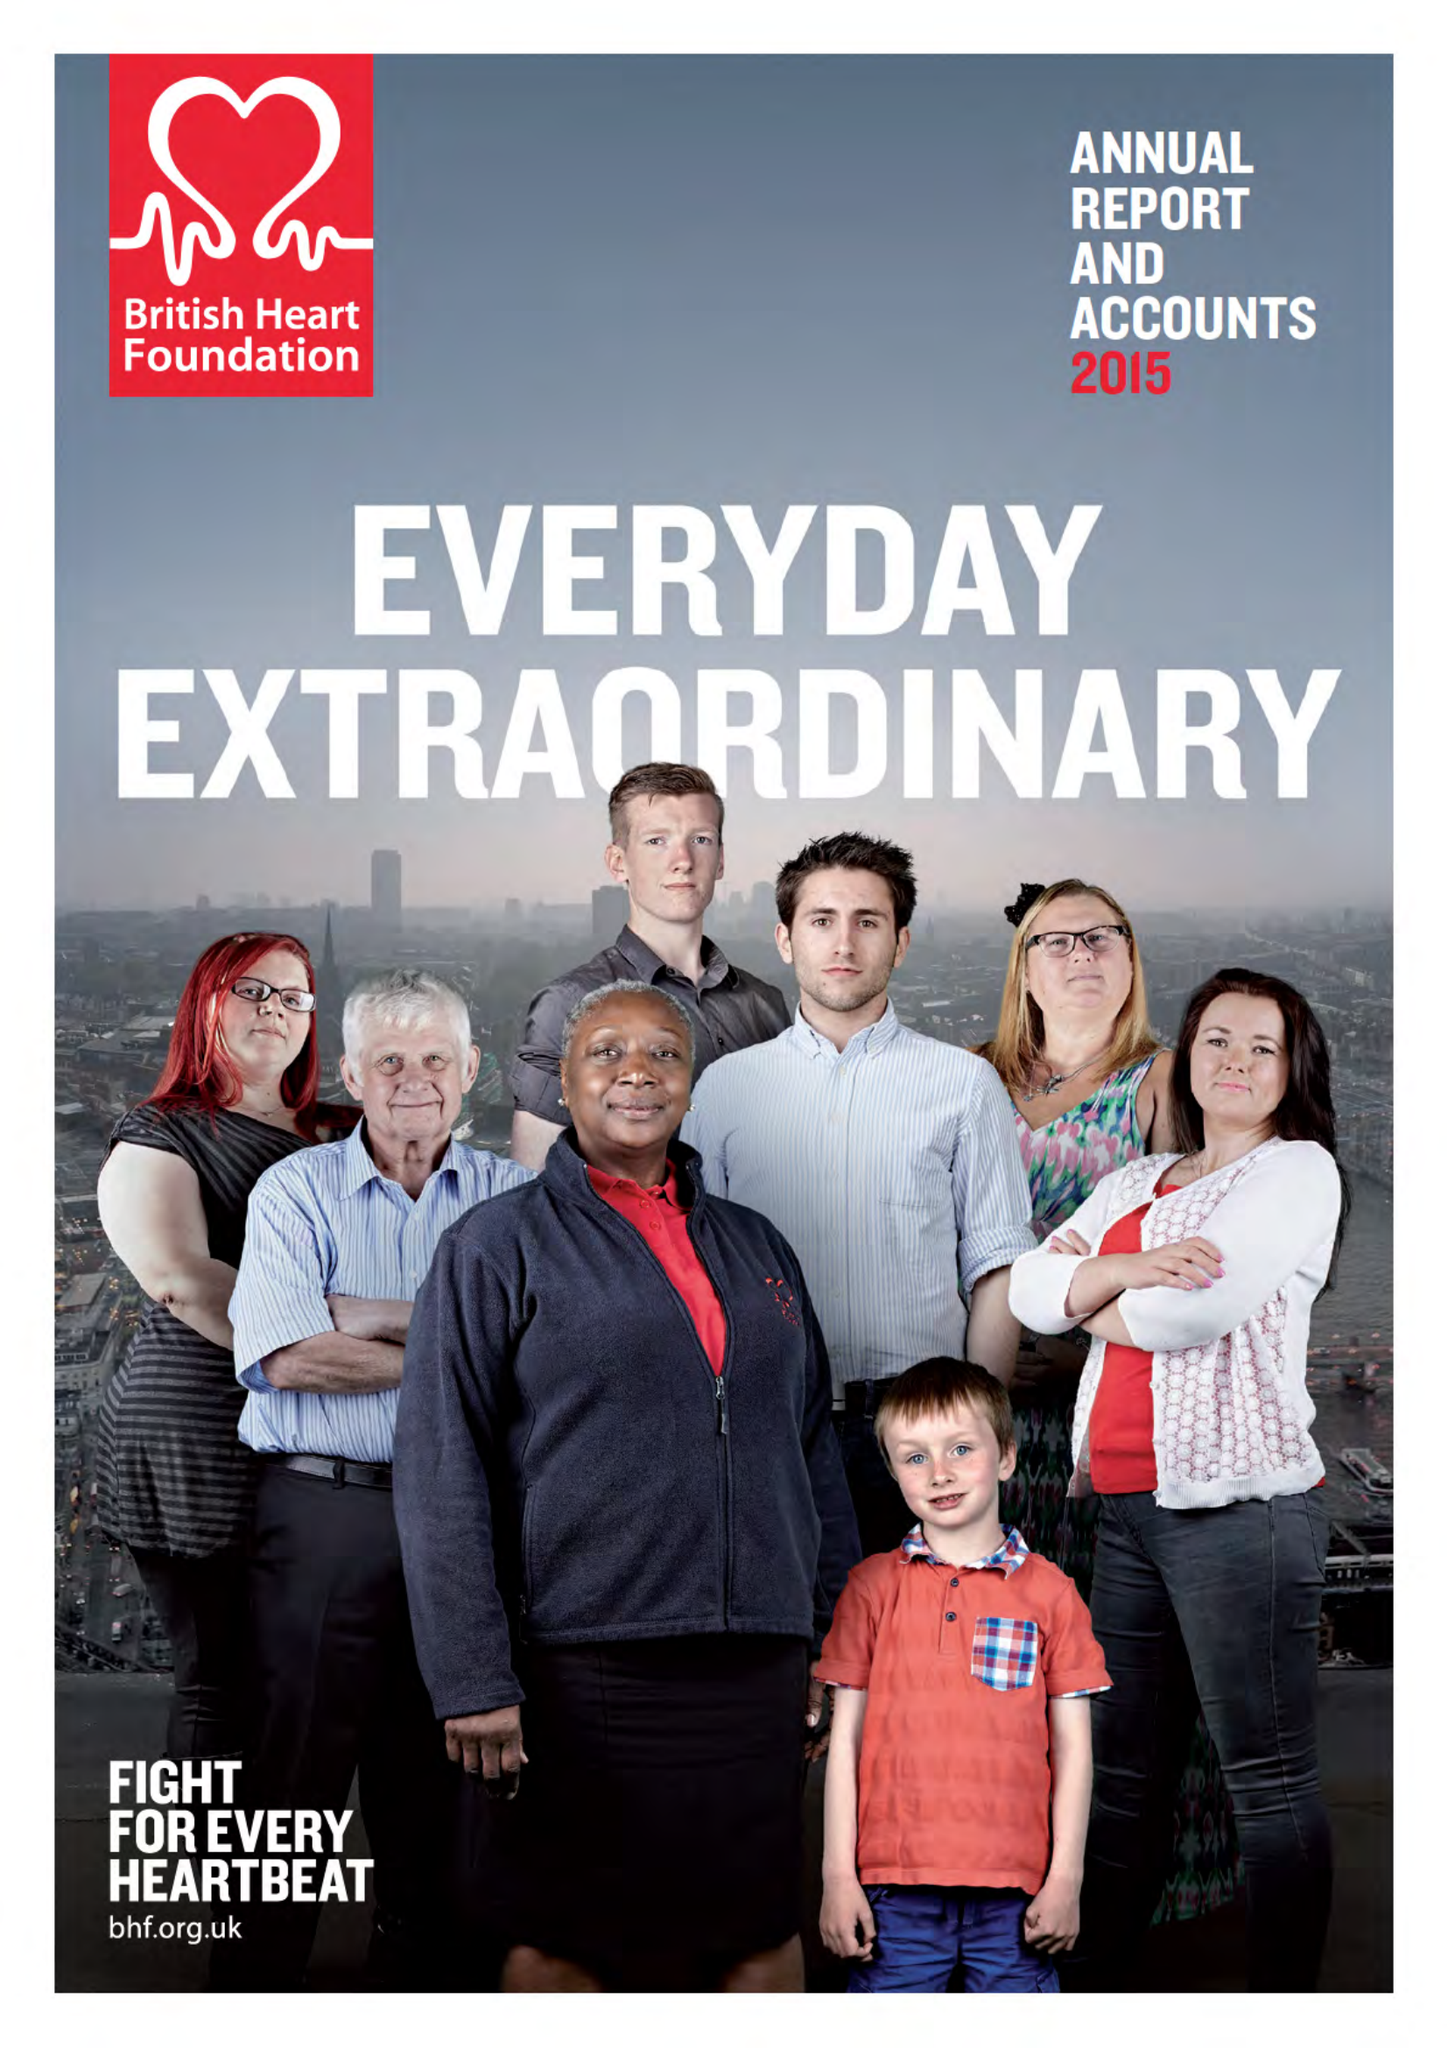What is the value for the spending_annually_in_british_pounds?
Answer the question using a single word or phrase. 287300000.00 